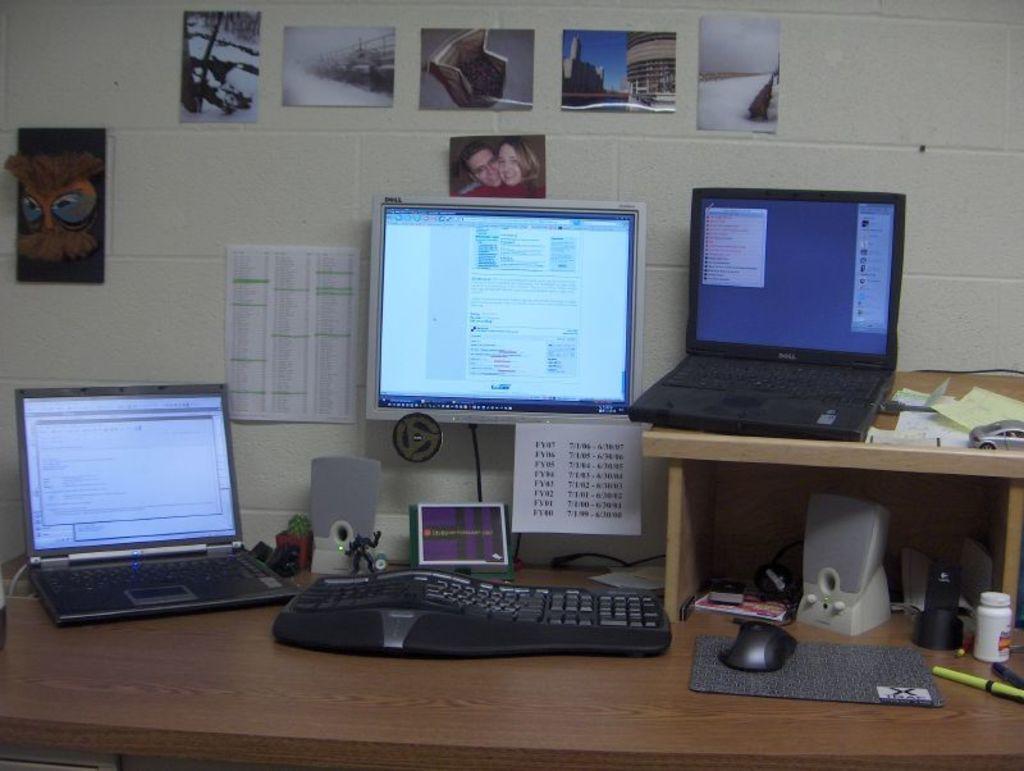Describe this image in one or two sentences. In this image there are two laptops are on the table. There is a keyboard, mouse, sound speakers, bottles, pens are on the table. There is a screen mounted on the wall having few photos and few papers are attached to the wall. 